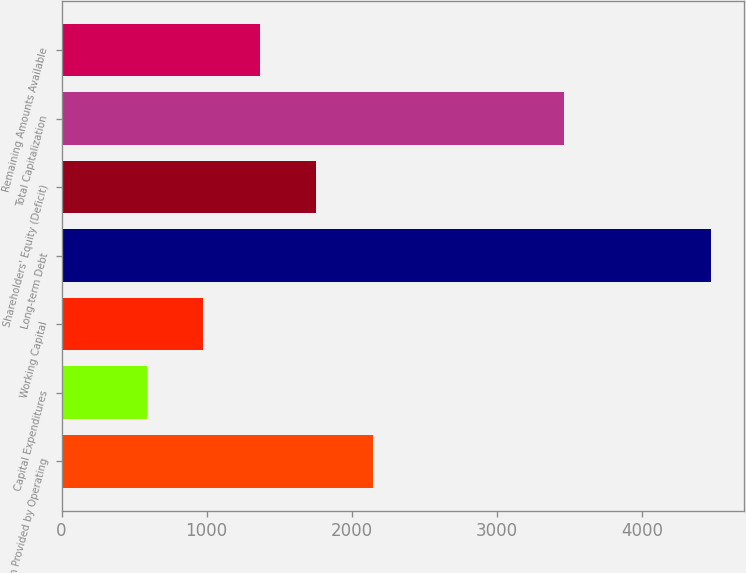<chart> <loc_0><loc_0><loc_500><loc_500><bar_chart><fcel>Cash Provided by Operating<fcel>Capital Expenditures<fcel>Working Capital<fcel>Long-term Debt<fcel>Shareholders' Equity (Deficit)<fcel>Total Capitalization<fcel>Remaining Amounts Available<nl><fcel>2143.6<fcel>588<fcel>976.9<fcel>4477<fcel>1754.7<fcel>3462<fcel>1365.8<nl></chart> 